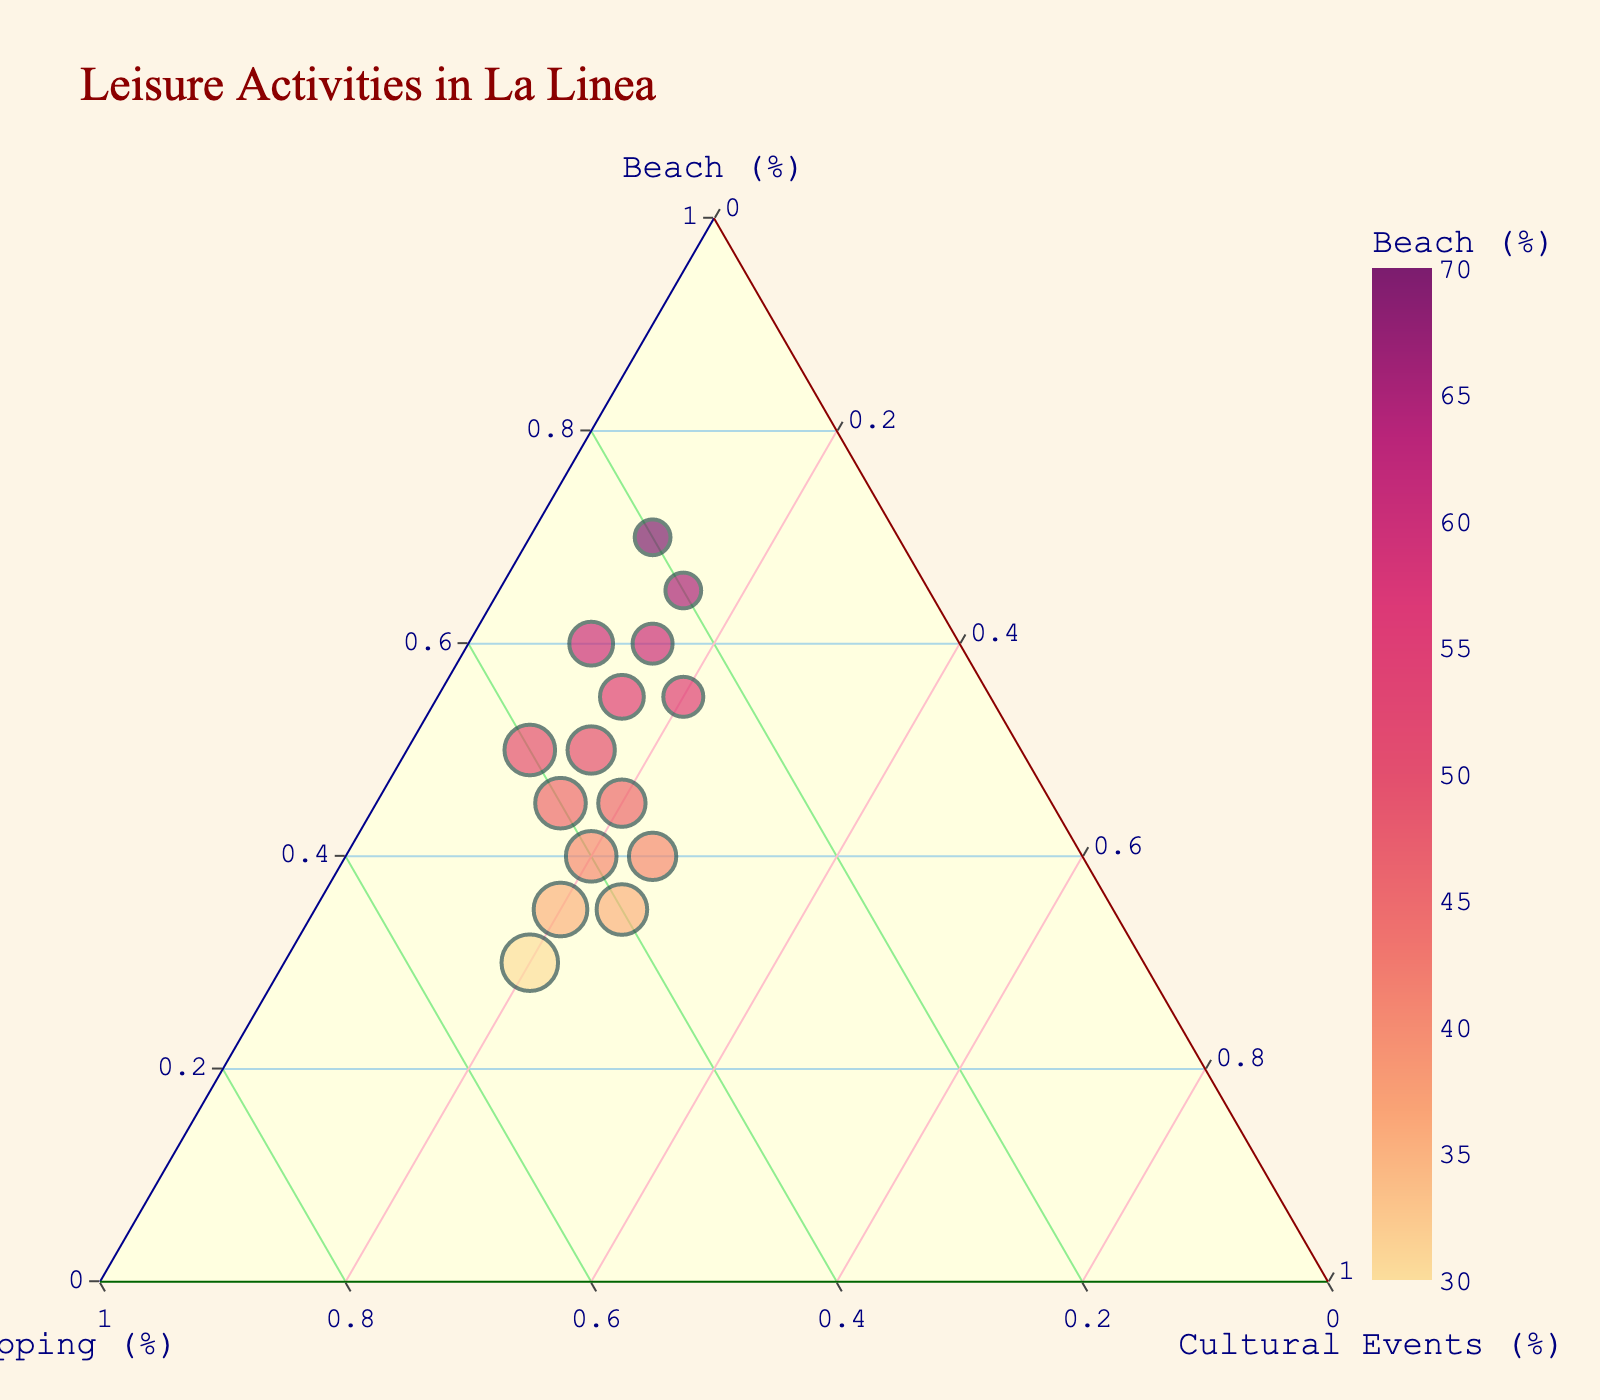How many data points are present in the figure? The figure shows 15 data points, which corresponds to the 15 rows in the data provided.
Answer: 15 What activity has the highest percentage among the residents of La Linea? By referring to the plotted data points, the activity with the highest percentage is the Beach, with data points reaching up to 70%.
Answer: Beach Which data point has equal percentages for Shopping and Cultural Events? By observing the plot, identify the data points where the Shopping and Cultural Events percentages are equal; one such point is 50, 40, 10 (where Shopping = Beach + Cultural Events).
Answer: 50, 40, 10 What is the average percentage of Beach activities for all data points? Sum the Beach percentages (60+45+55+40+50+65+35+55+45+70+30+50+40+60+35) and divide by the number of data points (15): (795/15).
Answer: 53 Which data point has the lowest percentage for Cultural Events? By examining the plot, identify the data point where Cultural Events have the minimum value, which is 10%.
Answer: 70, 20, 10 Compare the two data points with the highest percentage of Beach activities: which has a higher percentage for Shopping? The points to compare are (70, 20, 10) and (65, 20, 15). Between these, both have 20% for Shopping, so they are equal in this respect.
Answer: Equal Determine the median percentage for Cultural Events across all data points. Arrange the Cultural Events percentages in ascending order and find the middle value. The ordered percentages are: 10, 10, 10, 15, 15, 15, 15, 20, 20, 20, 20, 20, 25, 25, 25. The median is the eighth value.
Answer: 20 Which data point stands out as an outlier in terms of Beach activities? The highest Beach percentage (70) is significantly higher than other points and can be considered an outlier. One such point is (70, 20, 10).
Answer: 70, 20, 10 Between the data points where Shopping equals 40%, which one has the highest Beach percentage? The data points with Shopping = 40% are (40, 40, 20), (45, 40, 15), and (50, 40, 10). Among these, 50% Beach has the highest value.
Answer: 50, 40, 10 